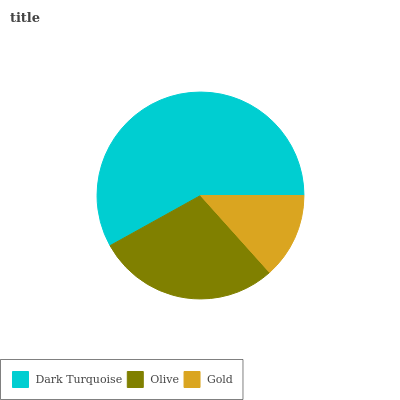Is Gold the minimum?
Answer yes or no. Yes. Is Dark Turquoise the maximum?
Answer yes or no. Yes. Is Olive the minimum?
Answer yes or no. No. Is Olive the maximum?
Answer yes or no. No. Is Dark Turquoise greater than Olive?
Answer yes or no. Yes. Is Olive less than Dark Turquoise?
Answer yes or no. Yes. Is Olive greater than Dark Turquoise?
Answer yes or no. No. Is Dark Turquoise less than Olive?
Answer yes or no. No. Is Olive the high median?
Answer yes or no. Yes. Is Olive the low median?
Answer yes or no. Yes. Is Gold the high median?
Answer yes or no. No. Is Dark Turquoise the low median?
Answer yes or no. No. 